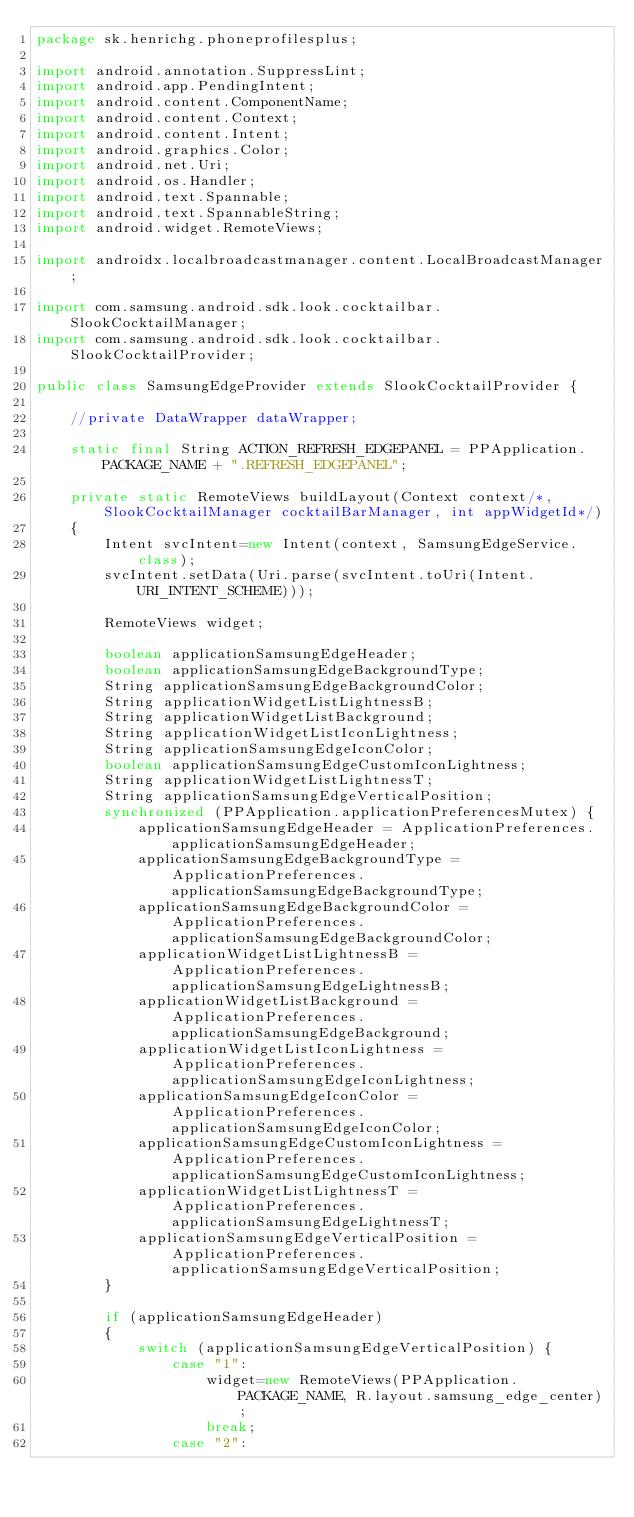<code> <loc_0><loc_0><loc_500><loc_500><_Java_>package sk.henrichg.phoneprofilesplus;

import android.annotation.SuppressLint;
import android.app.PendingIntent;
import android.content.ComponentName;
import android.content.Context;
import android.content.Intent;
import android.graphics.Color;
import android.net.Uri;
import android.os.Handler;
import android.text.Spannable;
import android.text.SpannableString;
import android.widget.RemoteViews;

import androidx.localbroadcastmanager.content.LocalBroadcastManager;

import com.samsung.android.sdk.look.cocktailbar.SlookCocktailManager;
import com.samsung.android.sdk.look.cocktailbar.SlookCocktailProvider;

public class SamsungEdgeProvider extends SlookCocktailProvider {

    //private DataWrapper dataWrapper;

    static final String ACTION_REFRESH_EDGEPANEL = PPApplication.PACKAGE_NAME + ".REFRESH_EDGEPANEL";

    private static RemoteViews buildLayout(Context context/*, SlookCocktailManager cocktailBarManager, int appWidgetId*/)
    {
        Intent svcIntent=new Intent(context, SamsungEdgeService.class);
        svcIntent.setData(Uri.parse(svcIntent.toUri(Intent.URI_INTENT_SCHEME)));

        RemoteViews widget;

        boolean applicationSamsungEdgeHeader;
        boolean applicationSamsungEdgeBackgroundType;
        String applicationSamsungEdgeBackgroundColor;
        String applicationWidgetListLightnessB;
        String applicationWidgetListBackground;
        String applicationWidgetListIconLightness;
        String applicationSamsungEdgeIconColor;
        boolean applicationSamsungEdgeCustomIconLightness;
        String applicationWidgetListLightnessT;
        String applicationSamsungEdgeVerticalPosition;
        synchronized (PPApplication.applicationPreferencesMutex) {
            applicationSamsungEdgeHeader = ApplicationPreferences.applicationSamsungEdgeHeader;
            applicationSamsungEdgeBackgroundType = ApplicationPreferences.applicationSamsungEdgeBackgroundType;
            applicationSamsungEdgeBackgroundColor = ApplicationPreferences.applicationSamsungEdgeBackgroundColor;
            applicationWidgetListLightnessB = ApplicationPreferences.applicationSamsungEdgeLightnessB;
            applicationWidgetListBackground = ApplicationPreferences.applicationSamsungEdgeBackground;
            applicationWidgetListIconLightness = ApplicationPreferences.applicationSamsungEdgeIconLightness;
            applicationSamsungEdgeIconColor = ApplicationPreferences.applicationSamsungEdgeIconColor;
            applicationSamsungEdgeCustomIconLightness = ApplicationPreferences.applicationSamsungEdgeCustomIconLightness;
            applicationWidgetListLightnessT = ApplicationPreferences.applicationSamsungEdgeLightnessT;
            applicationSamsungEdgeVerticalPosition = ApplicationPreferences.applicationSamsungEdgeVerticalPosition;
        }

        if (applicationSamsungEdgeHeader)
        {
            switch (applicationSamsungEdgeVerticalPosition) {
                case "1":
                    widget=new RemoteViews(PPApplication.PACKAGE_NAME, R.layout.samsung_edge_center);
                    break;
                case "2":</code> 